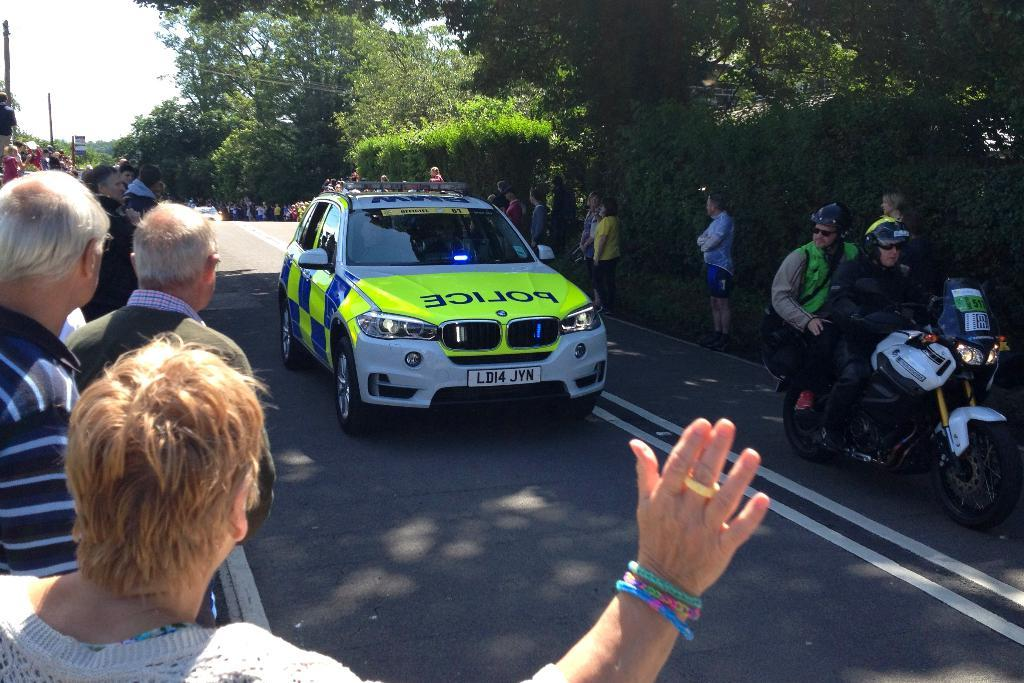What is the main subject of the image? A: The main subject of the image is a car on the road. Can you describe any other vehicles or objects in the image? Yes, there are two persons on a bike in the image. What else can be seen on the road in the image? There are people standing on the road in the image. What is visible in the background of the image? Trees and the sky are visible in the background of the image. How does the car generate heat in the image? The image does not provide information about the car's heat generation. What is the front of the car facing in the image? The image does not specify the direction the car is facing. 